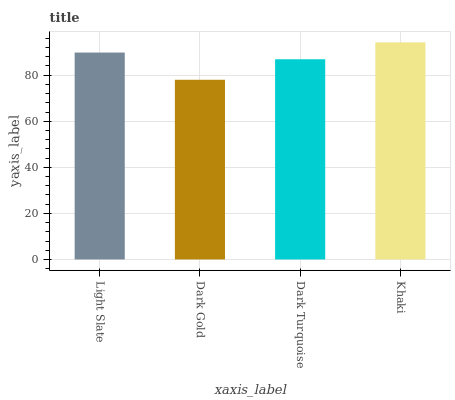Is Dark Gold the minimum?
Answer yes or no. Yes. Is Khaki the maximum?
Answer yes or no. Yes. Is Dark Turquoise the minimum?
Answer yes or no. No. Is Dark Turquoise the maximum?
Answer yes or no. No. Is Dark Turquoise greater than Dark Gold?
Answer yes or no. Yes. Is Dark Gold less than Dark Turquoise?
Answer yes or no. Yes. Is Dark Gold greater than Dark Turquoise?
Answer yes or no. No. Is Dark Turquoise less than Dark Gold?
Answer yes or no. No. Is Light Slate the high median?
Answer yes or no. Yes. Is Dark Turquoise the low median?
Answer yes or no. Yes. Is Dark Turquoise the high median?
Answer yes or no. No. Is Dark Gold the low median?
Answer yes or no. No. 